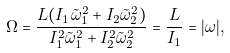<formula> <loc_0><loc_0><loc_500><loc_500>\Omega = \frac { L ( I _ { 1 } \tilde { \omega } _ { 1 } ^ { 2 } + I _ { 2 } \tilde { \omega } _ { 2 } ^ { 2 } ) } { I _ { 1 } ^ { 2 } \tilde { \omega } _ { 1 } ^ { 2 } + I _ { 2 } ^ { 2 } \tilde { \omega } _ { 2 } ^ { 2 } } = \frac { L } { I _ { 1 } } = | \omega | ,</formula> 